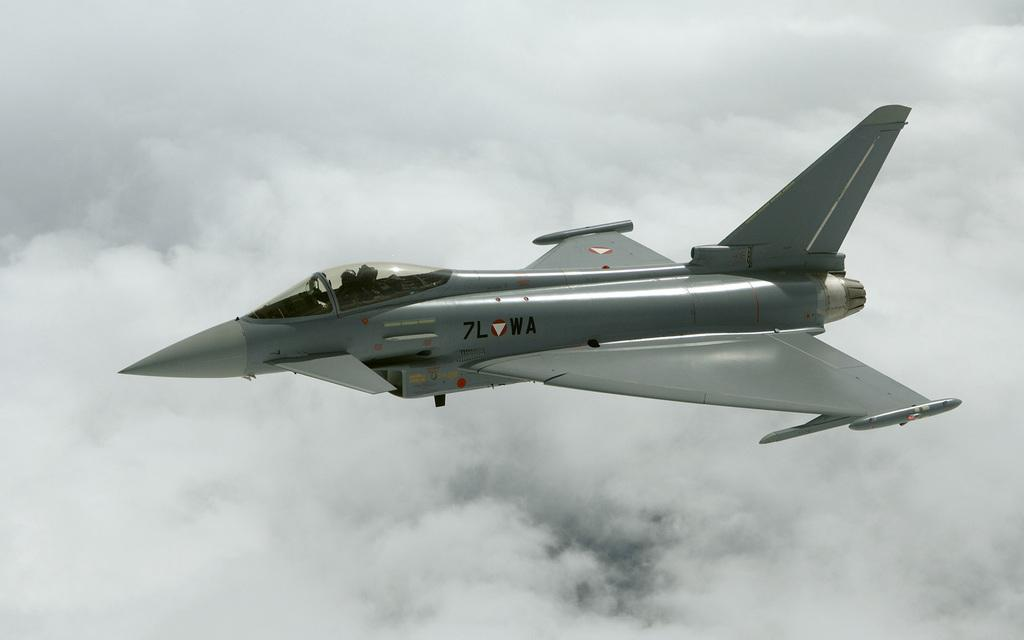What is the main subject of the picture? The main subject of the picture is an airplane. What is the color of the airplane? The airplane is grey in color. What is the airplane doing in the picture? The airplane is flying in the sky. What can be seen in the background of the image? There are clouds visible in the background of the image. What type of fan is visible in the image? There is no fan present in the image; it features an airplane flying in the sky. What type of drink is being served on the airplane in the image? There is no drink being served in the image, as it only shows an airplane flying in the sky. 